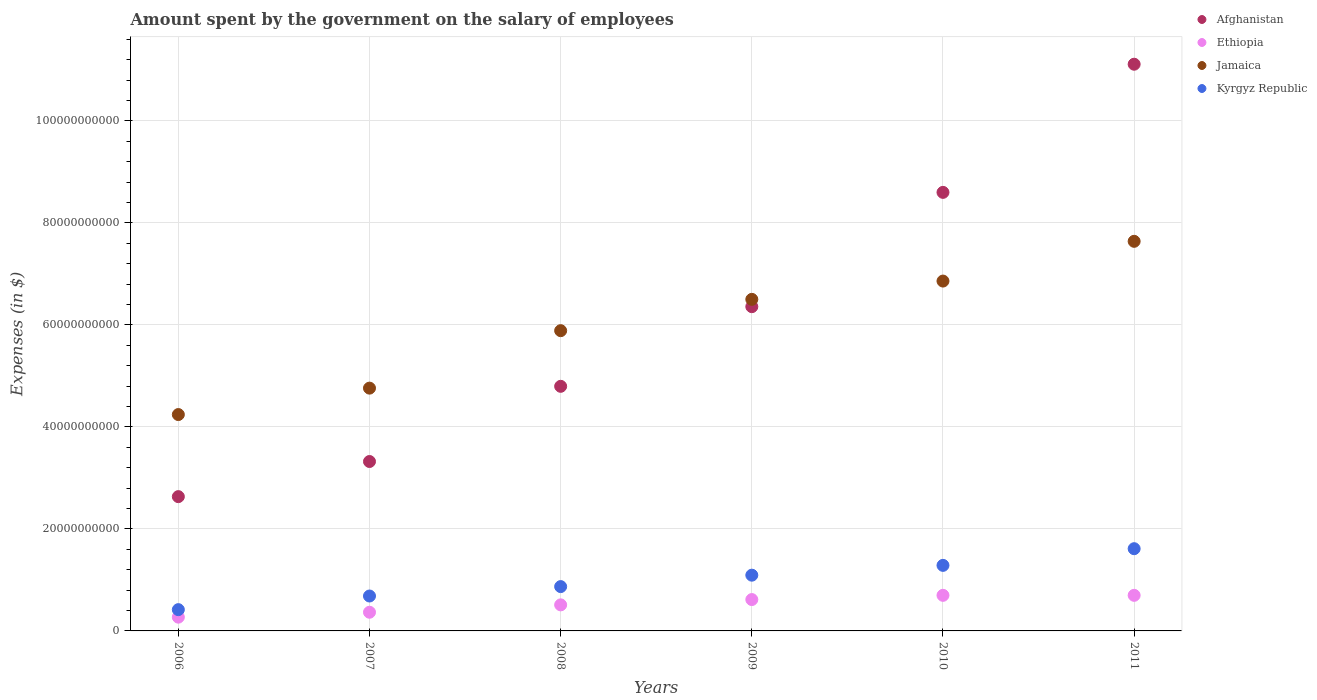Is the number of dotlines equal to the number of legend labels?
Your answer should be very brief. Yes. What is the amount spent on the salary of employees by the government in Afghanistan in 2011?
Offer a terse response. 1.11e+11. Across all years, what is the maximum amount spent on the salary of employees by the government in Afghanistan?
Your answer should be very brief. 1.11e+11. Across all years, what is the minimum amount spent on the salary of employees by the government in Jamaica?
Offer a terse response. 4.24e+1. In which year was the amount spent on the salary of employees by the government in Afghanistan maximum?
Your response must be concise. 2011. What is the total amount spent on the salary of employees by the government in Afghanistan in the graph?
Make the answer very short. 3.68e+11. What is the difference between the amount spent on the salary of employees by the government in Kyrgyz Republic in 2007 and that in 2011?
Your response must be concise. -9.28e+09. What is the difference between the amount spent on the salary of employees by the government in Kyrgyz Republic in 2011 and the amount spent on the salary of employees by the government in Afghanistan in 2007?
Your answer should be compact. -1.71e+1. What is the average amount spent on the salary of employees by the government in Afghanistan per year?
Keep it short and to the point. 6.14e+1. In the year 2008, what is the difference between the amount spent on the salary of employees by the government in Kyrgyz Republic and amount spent on the salary of employees by the government in Jamaica?
Offer a terse response. -5.02e+1. In how many years, is the amount spent on the salary of employees by the government in Ethiopia greater than 84000000000 $?
Your response must be concise. 0. What is the ratio of the amount spent on the salary of employees by the government in Kyrgyz Republic in 2007 to that in 2010?
Your answer should be very brief. 0.53. What is the difference between the highest and the second highest amount spent on the salary of employees by the government in Kyrgyz Republic?
Your answer should be very brief. 3.27e+09. What is the difference between the highest and the lowest amount spent on the salary of employees by the government in Kyrgyz Republic?
Provide a succinct answer. 1.20e+1. In how many years, is the amount spent on the salary of employees by the government in Kyrgyz Republic greater than the average amount spent on the salary of employees by the government in Kyrgyz Republic taken over all years?
Your response must be concise. 3. Is it the case that in every year, the sum of the amount spent on the salary of employees by the government in Afghanistan and amount spent on the salary of employees by the government in Ethiopia  is greater than the sum of amount spent on the salary of employees by the government in Kyrgyz Republic and amount spent on the salary of employees by the government in Jamaica?
Offer a very short reply. No. Is the amount spent on the salary of employees by the government in Jamaica strictly greater than the amount spent on the salary of employees by the government in Afghanistan over the years?
Offer a terse response. No. Is the amount spent on the salary of employees by the government in Afghanistan strictly less than the amount spent on the salary of employees by the government in Ethiopia over the years?
Provide a short and direct response. No. How many years are there in the graph?
Offer a terse response. 6. Are the values on the major ticks of Y-axis written in scientific E-notation?
Provide a succinct answer. No. Does the graph contain any zero values?
Offer a terse response. No. Does the graph contain grids?
Give a very brief answer. Yes. Where does the legend appear in the graph?
Keep it short and to the point. Top right. How many legend labels are there?
Give a very brief answer. 4. How are the legend labels stacked?
Keep it short and to the point. Vertical. What is the title of the graph?
Your response must be concise. Amount spent by the government on the salary of employees. What is the label or title of the X-axis?
Give a very brief answer. Years. What is the label or title of the Y-axis?
Ensure brevity in your answer.  Expenses (in $). What is the Expenses (in $) in Afghanistan in 2006?
Your answer should be very brief. 2.63e+1. What is the Expenses (in $) in Ethiopia in 2006?
Offer a very short reply. 2.70e+09. What is the Expenses (in $) in Jamaica in 2006?
Provide a short and direct response. 4.24e+1. What is the Expenses (in $) of Kyrgyz Republic in 2006?
Keep it short and to the point. 4.17e+09. What is the Expenses (in $) in Afghanistan in 2007?
Give a very brief answer. 3.32e+1. What is the Expenses (in $) of Ethiopia in 2007?
Give a very brief answer. 3.66e+09. What is the Expenses (in $) in Jamaica in 2007?
Your answer should be compact. 4.76e+1. What is the Expenses (in $) of Kyrgyz Republic in 2007?
Provide a succinct answer. 6.85e+09. What is the Expenses (in $) in Afghanistan in 2008?
Your answer should be compact. 4.80e+1. What is the Expenses (in $) in Ethiopia in 2008?
Make the answer very short. 5.11e+09. What is the Expenses (in $) of Jamaica in 2008?
Keep it short and to the point. 5.89e+1. What is the Expenses (in $) of Kyrgyz Republic in 2008?
Offer a terse response. 8.69e+09. What is the Expenses (in $) in Afghanistan in 2009?
Offer a very short reply. 6.36e+1. What is the Expenses (in $) of Ethiopia in 2009?
Keep it short and to the point. 6.15e+09. What is the Expenses (in $) of Jamaica in 2009?
Your answer should be compact. 6.50e+1. What is the Expenses (in $) of Kyrgyz Republic in 2009?
Provide a short and direct response. 1.09e+1. What is the Expenses (in $) in Afghanistan in 2010?
Your answer should be very brief. 8.60e+1. What is the Expenses (in $) of Ethiopia in 2010?
Give a very brief answer. 6.98e+09. What is the Expenses (in $) of Jamaica in 2010?
Make the answer very short. 6.86e+1. What is the Expenses (in $) of Kyrgyz Republic in 2010?
Your answer should be very brief. 1.29e+1. What is the Expenses (in $) of Afghanistan in 2011?
Your answer should be compact. 1.11e+11. What is the Expenses (in $) of Ethiopia in 2011?
Your answer should be very brief. 6.98e+09. What is the Expenses (in $) in Jamaica in 2011?
Offer a terse response. 7.64e+1. What is the Expenses (in $) in Kyrgyz Republic in 2011?
Your answer should be compact. 1.61e+1. Across all years, what is the maximum Expenses (in $) in Afghanistan?
Give a very brief answer. 1.11e+11. Across all years, what is the maximum Expenses (in $) in Ethiopia?
Offer a very short reply. 6.98e+09. Across all years, what is the maximum Expenses (in $) of Jamaica?
Offer a very short reply. 7.64e+1. Across all years, what is the maximum Expenses (in $) of Kyrgyz Republic?
Offer a very short reply. 1.61e+1. Across all years, what is the minimum Expenses (in $) of Afghanistan?
Provide a short and direct response. 2.63e+1. Across all years, what is the minimum Expenses (in $) of Ethiopia?
Ensure brevity in your answer.  2.70e+09. Across all years, what is the minimum Expenses (in $) of Jamaica?
Provide a succinct answer. 4.24e+1. Across all years, what is the minimum Expenses (in $) of Kyrgyz Republic?
Provide a short and direct response. 4.17e+09. What is the total Expenses (in $) in Afghanistan in the graph?
Provide a short and direct response. 3.68e+11. What is the total Expenses (in $) in Ethiopia in the graph?
Ensure brevity in your answer.  3.16e+1. What is the total Expenses (in $) of Jamaica in the graph?
Provide a succinct answer. 3.59e+11. What is the total Expenses (in $) in Kyrgyz Republic in the graph?
Make the answer very short. 5.96e+1. What is the difference between the Expenses (in $) of Afghanistan in 2006 and that in 2007?
Your answer should be compact. -6.89e+09. What is the difference between the Expenses (in $) of Ethiopia in 2006 and that in 2007?
Provide a short and direct response. -9.63e+08. What is the difference between the Expenses (in $) of Jamaica in 2006 and that in 2007?
Keep it short and to the point. -5.18e+09. What is the difference between the Expenses (in $) in Kyrgyz Republic in 2006 and that in 2007?
Keep it short and to the point. -2.67e+09. What is the difference between the Expenses (in $) in Afghanistan in 2006 and that in 2008?
Offer a terse response. -2.16e+1. What is the difference between the Expenses (in $) of Ethiopia in 2006 and that in 2008?
Provide a succinct answer. -2.41e+09. What is the difference between the Expenses (in $) of Jamaica in 2006 and that in 2008?
Make the answer very short. -1.64e+1. What is the difference between the Expenses (in $) of Kyrgyz Republic in 2006 and that in 2008?
Make the answer very short. -4.52e+09. What is the difference between the Expenses (in $) of Afghanistan in 2006 and that in 2009?
Provide a short and direct response. -3.72e+1. What is the difference between the Expenses (in $) of Ethiopia in 2006 and that in 2009?
Your response must be concise. -3.45e+09. What is the difference between the Expenses (in $) of Jamaica in 2006 and that in 2009?
Offer a very short reply. -2.26e+1. What is the difference between the Expenses (in $) in Kyrgyz Republic in 2006 and that in 2009?
Provide a short and direct response. -6.76e+09. What is the difference between the Expenses (in $) in Afghanistan in 2006 and that in 2010?
Provide a short and direct response. -5.97e+1. What is the difference between the Expenses (in $) in Ethiopia in 2006 and that in 2010?
Offer a terse response. -4.28e+09. What is the difference between the Expenses (in $) in Jamaica in 2006 and that in 2010?
Your response must be concise. -2.62e+1. What is the difference between the Expenses (in $) of Kyrgyz Republic in 2006 and that in 2010?
Your answer should be very brief. -8.68e+09. What is the difference between the Expenses (in $) of Afghanistan in 2006 and that in 2011?
Your answer should be very brief. -8.48e+1. What is the difference between the Expenses (in $) in Ethiopia in 2006 and that in 2011?
Give a very brief answer. -4.28e+09. What is the difference between the Expenses (in $) of Jamaica in 2006 and that in 2011?
Offer a terse response. -3.40e+1. What is the difference between the Expenses (in $) of Kyrgyz Republic in 2006 and that in 2011?
Ensure brevity in your answer.  -1.20e+1. What is the difference between the Expenses (in $) in Afghanistan in 2007 and that in 2008?
Offer a very short reply. -1.47e+1. What is the difference between the Expenses (in $) of Ethiopia in 2007 and that in 2008?
Keep it short and to the point. -1.45e+09. What is the difference between the Expenses (in $) in Jamaica in 2007 and that in 2008?
Keep it short and to the point. -1.13e+1. What is the difference between the Expenses (in $) in Kyrgyz Republic in 2007 and that in 2008?
Provide a succinct answer. -1.85e+09. What is the difference between the Expenses (in $) in Afghanistan in 2007 and that in 2009?
Offer a terse response. -3.04e+1. What is the difference between the Expenses (in $) in Ethiopia in 2007 and that in 2009?
Your answer should be very brief. -2.49e+09. What is the difference between the Expenses (in $) of Jamaica in 2007 and that in 2009?
Give a very brief answer. -1.74e+1. What is the difference between the Expenses (in $) in Kyrgyz Republic in 2007 and that in 2009?
Your answer should be very brief. -4.09e+09. What is the difference between the Expenses (in $) in Afghanistan in 2007 and that in 2010?
Give a very brief answer. -5.28e+1. What is the difference between the Expenses (in $) of Ethiopia in 2007 and that in 2010?
Your response must be concise. -3.32e+09. What is the difference between the Expenses (in $) of Jamaica in 2007 and that in 2010?
Offer a very short reply. -2.10e+1. What is the difference between the Expenses (in $) of Kyrgyz Republic in 2007 and that in 2010?
Give a very brief answer. -6.01e+09. What is the difference between the Expenses (in $) of Afghanistan in 2007 and that in 2011?
Provide a succinct answer. -7.79e+1. What is the difference between the Expenses (in $) in Ethiopia in 2007 and that in 2011?
Ensure brevity in your answer.  -3.32e+09. What is the difference between the Expenses (in $) of Jamaica in 2007 and that in 2011?
Provide a short and direct response. -2.88e+1. What is the difference between the Expenses (in $) of Kyrgyz Republic in 2007 and that in 2011?
Your answer should be very brief. -9.28e+09. What is the difference between the Expenses (in $) of Afghanistan in 2008 and that in 2009?
Offer a terse response. -1.56e+1. What is the difference between the Expenses (in $) of Ethiopia in 2008 and that in 2009?
Your response must be concise. -1.04e+09. What is the difference between the Expenses (in $) of Jamaica in 2008 and that in 2009?
Offer a very short reply. -6.14e+09. What is the difference between the Expenses (in $) of Kyrgyz Republic in 2008 and that in 2009?
Offer a very short reply. -2.24e+09. What is the difference between the Expenses (in $) of Afghanistan in 2008 and that in 2010?
Offer a terse response. -3.80e+1. What is the difference between the Expenses (in $) of Ethiopia in 2008 and that in 2010?
Offer a terse response. -1.87e+09. What is the difference between the Expenses (in $) of Jamaica in 2008 and that in 2010?
Provide a short and direct response. -9.73e+09. What is the difference between the Expenses (in $) in Kyrgyz Republic in 2008 and that in 2010?
Provide a short and direct response. -4.16e+09. What is the difference between the Expenses (in $) in Afghanistan in 2008 and that in 2011?
Keep it short and to the point. -6.32e+1. What is the difference between the Expenses (in $) in Ethiopia in 2008 and that in 2011?
Provide a succinct answer. -1.87e+09. What is the difference between the Expenses (in $) in Jamaica in 2008 and that in 2011?
Your answer should be very brief. -1.75e+1. What is the difference between the Expenses (in $) in Kyrgyz Republic in 2008 and that in 2011?
Offer a very short reply. -7.43e+09. What is the difference between the Expenses (in $) of Afghanistan in 2009 and that in 2010?
Provide a succinct answer. -2.24e+1. What is the difference between the Expenses (in $) of Ethiopia in 2009 and that in 2010?
Your response must be concise. -8.29e+08. What is the difference between the Expenses (in $) of Jamaica in 2009 and that in 2010?
Your response must be concise. -3.59e+09. What is the difference between the Expenses (in $) of Kyrgyz Republic in 2009 and that in 2010?
Your answer should be compact. -1.92e+09. What is the difference between the Expenses (in $) of Afghanistan in 2009 and that in 2011?
Provide a succinct answer. -4.75e+1. What is the difference between the Expenses (in $) of Ethiopia in 2009 and that in 2011?
Your answer should be very brief. -8.29e+08. What is the difference between the Expenses (in $) in Jamaica in 2009 and that in 2011?
Your answer should be very brief. -1.14e+1. What is the difference between the Expenses (in $) in Kyrgyz Republic in 2009 and that in 2011?
Keep it short and to the point. -5.19e+09. What is the difference between the Expenses (in $) of Afghanistan in 2010 and that in 2011?
Ensure brevity in your answer.  -2.51e+1. What is the difference between the Expenses (in $) in Ethiopia in 2010 and that in 2011?
Keep it short and to the point. 0. What is the difference between the Expenses (in $) in Jamaica in 2010 and that in 2011?
Provide a short and direct response. -7.79e+09. What is the difference between the Expenses (in $) in Kyrgyz Republic in 2010 and that in 2011?
Your response must be concise. -3.27e+09. What is the difference between the Expenses (in $) in Afghanistan in 2006 and the Expenses (in $) in Ethiopia in 2007?
Offer a very short reply. 2.27e+1. What is the difference between the Expenses (in $) in Afghanistan in 2006 and the Expenses (in $) in Jamaica in 2007?
Give a very brief answer. -2.13e+1. What is the difference between the Expenses (in $) in Afghanistan in 2006 and the Expenses (in $) in Kyrgyz Republic in 2007?
Offer a terse response. 1.95e+1. What is the difference between the Expenses (in $) of Ethiopia in 2006 and the Expenses (in $) of Jamaica in 2007?
Give a very brief answer. -4.49e+1. What is the difference between the Expenses (in $) in Ethiopia in 2006 and the Expenses (in $) in Kyrgyz Republic in 2007?
Your answer should be compact. -4.15e+09. What is the difference between the Expenses (in $) of Jamaica in 2006 and the Expenses (in $) of Kyrgyz Republic in 2007?
Give a very brief answer. 3.56e+1. What is the difference between the Expenses (in $) in Afghanistan in 2006 and the Expenses (in $) in Ethiopia in 2008?
Offer a terse response. 2.12e+1. What is the difference between the Expenses (in $) in Afghanistan in 2006 and the Expenses (in $) in Jamaica in 2008?
Give a very brief answer. -3.25e+1. What is the difference between the Expenses (in $) of Afghanistan in 2006 and the Expenses (in $) of Kyrgyz Republic in 2008?
Offer a very short reply. 1.76e+1. What is the difference between the Expenses (in $) in Ethiopia in 2006 and the Expenses (in $) in Jamaica in 2008?
Offer a terse response. -5.62e+1. What is the difference between the Expenses (in $) of Ethiopia in 2006 and the Expenses (in $) of Kyrgyz Republic in 2008?
Your response must be concise. -5.99e+09. What is the difference between the Expenses (in $) of Jamaica in 2006 and the Expenses (in $) of Kyrgyz Republic in 2008?
Your answer should be compact. 3.37e+1. What is the difference between the Expenses (in $) of Afghanistan in 2006 and the Expenses (in $) of Ethiopia in 2009?
Ensure brevity in your answer.  2.02e+1. What is the difference between the Expenses (in $) of Afghanistan in 2006 and the Expenses (in $) of Jamaica in 2009?
Give a very brief answer. -3.87e+1. What is the difference between the Expenses (in $) of Afghanistan in 2006 and the Expenses (in $) of Kyrgyz Republic in 2009?
Offer a terse response. 1.54e+1. What is the difference between the Expenses (in $) in Ethiopia in 2006 and the Expenses (in $) in Jamaica in 2009?
Offer a very short reply. -6.23e+1. What is the difference between the Expenses (in $) in Ethiopia in 2006 and the Expenses (in $) in Kyrgyz Republic in 2009?
Your answer should be very brief. -8.23e+09. What is the difference between the Expenses (in $) of Jamaica in 2006 and the Expenses (in $) of Kyrgyz Republic in 2009?
Your response must be concise. 3.15e+1. What is the difference between the Expenses (in $) of Afghanistan in 2006 and the Expenses (in $) of Ethiopia in 2010?
Ensure brevity in your answer.  1.94e+1. What is the difference between the Expenses (in $) of Afghanistan in 2006 and the Expenses (in $) of Jamaica in 2010?
Your answer should be very brief. -4.23e+1. What is the difference between the Expenses (in $) in Afghanistan in 2006 and the Expenses (in $) in Kyrgyz Republic in 2010?
Provide a short and direct response. 1.35e+1. What is the difference between the Expenses (in $) of Ethiopia in 2006 and the Expenses (in $) of Jamaica in 2010?
Give a very brief answer. -6.59e+1. What is the difference between the Expenses (in $) in Ethiopia in 2006 and the Expenses (in $) in Kyrgyz Republic in 2010?
Your answer should be very brief. -1.02e+1. What is the difference between the Expenses (in $) in Jamaica in 2006 and the Expenses (in $) in Kyrgyz Republic in 2010?
Offer a terse response. 2.96e+1. What is the difference between the Expenses (in $) of Afghanistan in 2006 and the Expenses (in $) of Ethiopia in 2011?
Your response must be concise. 1.94e+1. What is the difference between the Expenses (in $) of Afghanistan in 2006 and the Expenses (in $) of Jamaica in 2011?
Give a very brief answer. -5.01e+1. What is the difference between the Expenses (in $) in Afghanistan in 2006 and the Expenses (in $) in Kyrgyz Republic in 2011?
Give a very brief answer. 1.02e+1. What is the difference between the Expenses (in $) of Ethiopia in 2006 and the Expenses (in $) of Jamaica in 2011?
Offer a terse response. -7.37e+1. What is the difference between the Expenses (in $) of Ethiopia in 2006 and the Expenses (in $) of Kyrgyz Republic in 2011?
Offer a terse response. -1.34e+1. What is the difference between the Expenses (in $) in Jamaica in 2006 and the Expenses (in $) in Kyrgyz Republic in 2011?
Provide a short and direct response. 2.63e+1. What is the difference between the Expenses (in $) of Afghanistan in 2007 and the Expenses (in $) of Ethiopia in 2008?
Offer a terse response. 2.81e+1. What is the difference between the Expenses (in $) of Afghanistan in 2007 and the Expenses (in $) of Jamaica in 2008?
Ensure brevity in your answer.  -2.57e+1. What is the difference between the Expenses (in $) of Afghanistan in 2007 and the Expenses (in $) of Kyrgyz Republic in 2008?
Ensure brevity in your answer.  2.45e+1. What is the difference between the Expenses (in $) in Ethiopia in 2007 and the Expenses (in $) in Jamaica in 2008?
Offer a very short reply. -5.52e+1. What is the difference between the Expenses (in $) of Ethiopia in 2007 and the Expenses (in $) of Kyrgyz Republic in 2008?
Offer a terse response. -5.03e+09. What is the difference between the Expenses (in $) in Jamaica in 2007 and the Expenses (in $) in Kyrgyz Republic in 2008?
Offer a terse response. 3.89e+1. What is the difference between the Expenses (in $) of Afghanistan in 2007 and the Expenses (in $) of Ethiopia in 2009?
Provide a succinct answer. 2.71e+1. What is the difference between the Expenses (in $) in Afghanistan in 2007 and the Expenses (in $) in Jamaica in 2009?
Provide a short and direct response. -3.18e+1. What is the difference between the Expenses (in $) of Afghanistan in 2007 and the Expenses (in $) of Kyrgyz Republic in 2009?
Provide a short and direct response. 2.23e+1. What is the difference between the Expenses (in $) in Ethiopia in 2007 and the Expenses (in $) in Jamaica in 2009?
Offer a very short reply. -6.14e+1. What is the difference between the Expenses (in $) of Ethiopia in 2007 and the Expenses (in $) of Kyrgyz Republic in 2009?
Your answer should be very brief. -7.27e+09. What is the difference between the Expenses (in $) of Jamaica in 2007 and the Expenses (in $) of Kyrgyz Republic in 2009?
Ensure brevity in your answer.  3.67e+1. What is the difference between the Expenses (in $) of Afghanistan in 2007 and the Expenses (in $) of Ethiopia in 2010?
Your answer should be very brief. 2.62e+1. What is the difference between the Expenses (in $) in Afghanistan in 2007 and the Expenses (in $) in Jamaica in 2010?
Offer a terse response. -3.54e+1. What is the difference between the Expenses (in $) in Afghanistan in 2007 and the Expenses (in $) in Kyrgyz Republic in 2010?
Make the answer very short. 2.04e+1. What is the difference between the Expenses (in $) in Ethiopia in 2007 and the Expenses (in $) in Jamaica in 2010?
Provide a succinct answer. -6.49e+1. What is the difference between the Expenses (in $) in Ethiopia in 2007 and the Expenses (in $) in Kyrgyz Republic in 2010?
Provide a succinct answer. -9.19e+09. What is the difference between the Expenses (in $) in Jamaica in 2007 and the Expenses (in $) in Kyrgyz Republic in 2010?
Make the answer very short. 3.48e+1. What is the difference between the Expenses (in $) in Afghanistan in 2007 and the Expenses (in $) in Ethiopia in 2011?
Provide a succinct answer. 2.62e+1. What is the difference between the Expenses (in $) in Afghanistan in 2007 and the Expenses (in $) in Jamaica in 2011?
Your answer should be very brief. -4.32e+1. What is the difference between the Expenses (in $) of Afghanistan in 2007 and the Expenses (in $) of Kyrgyz Republic in 2011?
Offer a very short reply. 1.71e+1. What is the difference between the Expenses (in $) in Ethiopia in 2007 and the Expenses (in $) in Jamaica in 2011?
Ensure brevity in your answer.  -7.27e+1. What is the difference between the Expenses (in $) in Ethiopia in 2007 and the Expenses (in $) in Kyrgyz Republic in 2011?
Keep it short and to the point. -1.25e+1. What is the difference between the Expenses (in $) in Jamaica in 2007 and the Expenses (in $) in Kyrgyz Republic in 2011?
Offer a very short reply. 3.15e+1. What is the difference between the Expenses (in $) of Afghanistan in 2008 and the Expenses (in $) of Ethiopia in 2009?
Make the answer very short. 4.18e+1. What is the difference between the Expenses (in $) in Afghanistan in 2008 and the Expenses (in $) in Jamaica in 2009?
Offer a very short reply. -1.71e+1. What is the difference between the Expenses (in $) of Afghanistan in 2008 and the Expenses (in $) of Kyrgyz Republic in 2009?
Give a very brief answer. 3.70e+1. What is the difference between the Expenses (in $) in Ethiopia in 2008 and the Expenses (in $) in Jamaica in 2009?
Offer a very short reply. -5.99e+1. What is the difference between the Expenses (in $) in Ethiopia in 2008 and the Expenses (in $) in Kyrgyz Republic in 2009?
Provide a succinct answer. -5.82e+09. What is the difference between the Expenses (in $) of Jamaica in 2008 and the Expenses (in $) of Kyrgyz Republic in 2009?
Offer a very short reply. 4.79e+1. What is the difference between the Expenses (in $) in Afghanistan in 2008 and the Expenses (in $) in Ethiopia in 2010?
Provide a succinct answer. 4.10e+1. What is the difference between the Expenses (in $) of Afghanistan in 2008 and the Expenses (in $) of Jamaica in 2010?
Offer a very short reply. -2.06e+1. What is the difference between the Expenses (in $) of Afghanistan in 2008 and the Expenses (in $) of Kyrgyz Republic in 2010?
Ensure brevity in your answer.  3.51e+1. What is the difference between the Expenses (in $) of Ethiopia in 2008 and the Expenses (in $) of Jamaica in 2010?
Ensure brevity in your answer.  -6.35e+1. What is the difference between the Expenses (in $) in Ethiopia in 2008 and the Expenses (in $) in Kyrgyz Republic in 2010?
Your response must be concise. -7.74e+09. What is the difference between the Expenses (in $) in Jamaica in 2008 and the Expenses (in $) in Kyrgyz Republic in 2010?
Ensure brevity in your answer.  4.60e+1. What is the difference between the Expenses (in $) in Afghanistan in 2008 and the Expenses (in $) in Ethiopia in 2011?
Your response must be concise. 4.10e+1. What is the difference between the Expenses (in $) in Afghanistan in 2008 and the Expenses (in $) in Jamaica in 2011?
Your response must be concise. -2.84e+1. What is the difference between the Expenses (in $) of Afghanistan in 2008 and the Expenses (in $) of Kyrgyz Republic in 2011?
Provide a succinct answer. 3.18e+1. What is the difference between the Expenses (in $) in Ethiopia in 2008 and the Expenses (in $) in Jamaica in 2011?
Offer a very short reply. -7.13e+1. What is the difference between the Expenses (in $) in Ethiopia in 2008 and the Expenses (in $) in Kyrgyz Republic in 2011?
Make the answer very short. -1.10e+1. What is the difference between the Expenses (in $) in Jamaica in 2008 and the Expenses (in $) in Kyrgyz Republic in 2011?
Your response must be concise. 4.27e+1. What is the difference between the Expenses (in $) of Afghanistan in 2009 and the Expenses (in $) of Ethiopia in 2010?
Ensure brevity in your answer.  5.66e+1. What is the difference between the Expenses (in $) of Afghanistan in 2009 and the Expenses (in $) of Jamaica in 2010?
Offer a very short reply. -5.02e+09. What is the difference between the Expenses (in $) of Afghanistan in 2009 and the Expenses (in $) of Kyrgyz Republic in 2010?
Your answer should be compact. 5.07e+1. What is the difference between the Expenses (in $) of Ethiopia in 2009 and the Expenses (in $) of Jamaica in 2010?
Give a very brief answer. -6.25e+1. What is the difference between the Expenses (in $) of Ethiopia in 2009 and the Expenses (in $) of Kyrgyz Republic in 2010?
Provide a succinct answer. -6.70e+09. What is the difference between the Expenses (in $) in Jamaica in 2009 and the Expenses (in $) in Kyrgyz Republic in 2010?
Your answer should be compact. 5.22e+1. What is the difference between the Expenses (in $) in Afghanistan in 2009 and the Expenses (in $) in Ethiopia in 2011?
Keep it short and to the point. 5.66e+1. What is the difference between the Expenses (in $) in Afghanistan in 2009 and the Expenses (in $) in Jamaica in 2011?
Make the answer very short. -1.28e+1. What is the difference between the Expenses (in $) in Afghanistan in 2009 and the Expenses (in $) in Kyrgyz Republic in 2011?
Offer a very short reply. 4.75e+1. What is the difference between the Expenses (in $) in Ethiopia in 2009 and the Expenses (in $) in Jamaica in 2011?
Provide a succinct answer. -7.02e+1. What is the difference between the Expenses (in $) in Ethiopia in 2009 and the Expenses (in $) in Kyrgyz Republic in 2011?
Your response must be concise. -9.98e+09. What is the difference between the Expenses (in $) of Jamaica in 2009 and the Expenses (in $) of Kyrgyz Republic in 2011?
Your response must be concise. 4.89e+1. What is the difference between the Expenses (in $) of Afghanistan in 2010 and the Expenses (in $) of Ethiopia in 2011?
Give a very brief answer. 7.90e+1. What is the difference between the Expenses (in $) of Afghanistan in 2010 and the Expenses (in $) of Jamaica in 2011?
Ensure brevity in your answer.  9.60e+09. What is the difference between the Expenses (in $) in Afghanistan in 2010 and the Expenses (in $) in Kyrgyz Republic in 2011?
Give a very brief answer. 6.99e+1. What is the difference between the Expenses (in $) of Ethiopia in 2010 and the Expenses (in $) of Jamaica in 2011?
Your response must be concise. -6.94e+1. What is the difference between the Expenses (in $) in Ethiopia in 2010 and the Expenses (in $) in Kyrgyz Republic in 2011?
Make the answer very short. -9.15e+09. What is the difference between the Expenses (in $) of Jamaica in 2010 and the Expenses (in $) of Kyrgyz Republic in 2011?
Your answer should be very brief. 5.25e+1. What is the average Expenses (in $) of Afghanistan per year?
Give a very brief answer. 6.14e+1. What is the average Expenses (in $) in Ethiopia per year?
Your answer should be compact. 5.26e+09. What is the average Expenses (in $) of Jamaica per year?
Make the answer very short. 5.98e+1. What is the average Expenses (in $) of Kyrgyz Republic per year?
Give a very brief answer. 9.94e+09. In the year 2006, what is the difference between the Expenses (in $) of Afghanistan and Expenses (in $) of Ethiopia?
Keep it short and to the point. 2.36e+1. In the year 2006, what is the difference between the Expenses (in $) in Afghanistan and Expenses (in $) in Jamaica?
Offer a terse response. -1.61e+1. In the year 2006, what is the difference between the Expenses (in $) of Afghanistan and Expenses (in $) of Kyrgyz Republic?
Your answer should be very brief. 2.22e+1. In the year 2006, what is the difference between the Expenses (in $) in Ethiopia and Expenses (in $) in Jamaica?
Offer a terse response. -3.97e+1. In the year 2006, what is the difference between the Expenses (in $) of Ethiopia and Expenses (in $) of Kyrgyz Republic?
Your answer should be compact. -1.47e+09. In the year 2006, what is the difference between the Expenses (in $) of Jamaica and Expenses (in $) of Kyrgyz Republic?
Your response must be concise. 3.83e+1. In the year 2007, what is the difference between the Expenses (in $) in Afghanistan and Expenses (in $) in Ethiopia?
Make the answer very short. 2.96e+1. In the year 2007, what is the difference between the Expenses (in $) of Afghanistan and Expenses (in $) of Jamaica?
Provide a short and direct response. -1.44e+1. In the year 2007, what is the difference between the Expenses (in $) in Afghanistan and Expenses (in $) in Kyrgyz Republic?
Provide a short and direct response. 2.64e+1. In the year 2007, what is the difference between the Expenses (in $) in Ethiopia and Expenses (in $) in Jamaica?
Make the answer very short. -4.39e+1. In the year 2007, what is the difference between the Expenses (in $) of Ethiopia and Expenses (in $) of Kyrgyz Republic?
Keep it short and to the point. -3.18e+09. In the year 2007, what is the difference between the Expenses (in $) in Jamaica and Expenses (in $) in Kyrgyz Republic?
Provide a succinct answer. 4.08e+1. In the year 2008, what is the difference between the Expenses (in $) in Afghanistan and Expenses (in $) in Ethiopia?
Make the answer very short. 4.29e+1. In the year 2008, what is the difference between the Expenses (in $) in Afghanistan and Expenses (in $) in Jamaica?
Your answer should be very brief. -1.09e+1. In the year 2008, what is the difference between the Expenses (in $) in Afghanistan and Expenses (in $) in Kyrgyz Republic?
Offer a terse response. 3.93e+1. In the year 2008, what is the difference between the Expenses (in $) in Ethiopia and Expenses (in $) in Jamaica?
Provide a short and direct response. -5.38e+1. In the year 2008, what is the difference between the Expenses (in $) in Ethiopia and Expenses (in $) in Kyrgyz Republic?
Offer a terse response. -3.58e+09. In the year 2008, what is the difference between the Expenses (in $) in Jamaica and Expenses (in $) in Kyrgyz Republic?
Give a very brief answer. 5.02e+1. In the year 2009, what is the difference between the Expenses (in $) in Afghanistan and Expenses (in $) in Ethiopia?
Give a very brief answer. 5.74e+1. In the year 2009, what is the difference between the Expenses (in $) of Afghanistan and Expenses (in $) of Jamaica?
Keep it short and to the point. -1.44e+09. In the year 2009, what is the difference between the Expenses (in $) of Afghanistan and Expenses (in $) of Kyrgyz Republic?
Offer a terse response. 5.26e+1. In the year 2009, what is the difference between the Expenses (in $) of Ethiopia and Expenses (in $) of Jamaica?
Your response must be concise. -5.89e+1. In the year 2009, what is the difference between the Expenses (in $) in Ethiopia and Expenses (in $) in Kyrgyz Republic?
Provide a succinct answer. -4.78e+09. In the year 2009, what is the difference between the Expenses (in $) of Jamaica and Expenses (in $) of Kyrgyz Republic?
Your answer should be very brief. 5.41e+1. In the year 2010, what is the difference between the Expenses (in $) of Afghanistan and Expenses (in $) of Ethiopia?
Provide a short and direct response. 7.90e+1. In the year 2010, what is the difference between the Expenses (in $) of Afghanistan and Expenses (in $) of Jamaica?
Offer a terse response. 1.74e+1. In the year 2010, what is the difference between the Expenses (in $) of Afghanistan and Expenses (in $) of Kyrgyz Republic?
Offer a very short reply. 7.31e+1. In the year 2010, what is the difference between the Expenses (in $) of Ethiopia and Expenses (in $) of Jamaica?
Ensure brevity in your answer.  -6.16e+1. In the year 2010, what is the difference between the Expenses (in $) in Ethiopia and Expenses (in $) in Kyrgyz Republic?
Your response must be concise. -5.87e+09. In the year 2010, what is the difference between the Expenses (in $) of Jamaica and Expenses (in $) of Kyrgyz Republic?
Keep it short and to the point. 5.57e+1. In the year 2011, what is the difference between the Expenses (in $) in Afghanistan and Expenses (in $) in Ethiopia?
Your answer should be very brief. 1.04e+11. In the year 2011, what is the difference between the Expenses (in $) of Afghanistan and Expenses (in $) of Jamaica?
Your answer should be compact. 3.47e+1. In the year 2011, what is the difference between the Expenses (in $) of Afghanistan and Expenses (in $) of Kyrgyz Republic?
Give a very brief answer. 9.50e+1. In the year 2011, what is the difference between the Expenses (in $) of Ethiopia and Expenses (in $) of Jamaica?
Your response must be concise. -6.94e+1. In the year 2011, what is the difference between the Expenses (in $) in Ethiopia and Expenses (in $) in Kyrgyz Republic?
Keep it short and to the point. -9.15e+09. In the year 2011, what is the difference between the Expenses (in $) of Jamaica and Expenses (in $) of Kyrgyz Republic?
Give a very brief answer. 6.03e+1. What is the ratio of the Expenses (in $) in Afghanistan in 2006 to that in 2007?
Keep it short and to the point. 0.79. What is the ratio of the Expenses (in $) in Ethiopia in 2006 to that in 2007?
Your response must be concise. 0.74. What is the ratio of the Expenses (in $) of Jamaica in 2006 to that in 2007?
Your answer should be compact. 0.89. What is the ratio of the Expenses (in $) in Kyrgyz Republic in 2006 to that in 2007?
Your answer should be compact. 0.61. What is the ratio of the Expenses (in $) of Afghanistan in 2006 to that in 2008?
Your response must be concise. 0.55. What is the ratio of the Expenses (in $) in Ethiopia in 2006 to that in 2008?
Keep it short and to the point. 0.53. What is the ratio of the Expenses (in $) of Jamaica in 2006 to that in 2008?
Give a very brief answer. 0.72. What is the ratio of the Expenses (in $) of Kyrgyz Republic in 2006 to that in 2008?
Keep it short and to the point. 0.48. What is the ratio of the Expenses (in $) in Afghanistan in 2006 to that in 2009?
Your response must be concise. 0.41. What is the ratio of the Expenses (in $) in Ethiopia in 2006 to that in 2009?
Your answer should be very brief. 0.44. What is the ratio of the Expenses (in $) in Jamaica in 2006 to that in 2009?
Make the answer very short. 0.65. What is the ratio of the Expenses (in $) of Kyrgyz Republic in 2006 to that in 2009?
Offer a terse response. 0.38. What is the ratio of the Expenses (in $) of Afghanistan in 2006 to that in 2010?
Your response must be concise. 0.31. What is the ratio of the Expenses (in $) in Ethiopia in 2006 to that in 2010?
Make the answer very short. 0.39. What is the ratio of the Expenses (in $) of Jamaica in 2006 to that in 2010?
Provide a short and direct response. 0.62. What is the ratio of the Expenses (in $) of Kyrgyz Republic in 2006 to that in 2010?
Your answer should be very brief. 0.32. What is the ratio of the Expenses (in $) in Afghanistan in 2006 to that in 2011?
Provide a short and direct response. 0.24. What is the ratio of the Expenses (in $) of Ethiopia in 2006 to that in 2011?
Your answer should be compact. 0.39. What is the ratio of the Expenses (in $) of Jamaica in 2006 to that in 2011?
Provide a short and direct response. 0.56. What is the ratio of the Expenses (in $) in Kyrgyz Republic in 2006 to that in 2011?
Ensure brevity in your answer.  0.26. What is the ratio of the Expenses (in $) in Afghanistan in 2007 to that in 2008?
Keep it short and to the point. 0.69. What is the ratio of the Expenses (in $) in Ethiopia in 2007 to that in 2008?
Offer a very short reply. 0.72. What is the ratio of the Expenses (in $) in Jamaica in 2007 to that in 2008?
Offer a terse response. 0.81. What is the ratio of the Expenses (in $) in Kyrgyz Republic in 2007 to that in 2008?
Your answer should be compact. 0.79. What is the ratio of the Expenses (in $) in Afghanistan in 2007 to that in 2009?
Ensure brevity in your answer.  0.52. What is the ratio of the Expenses (in $) in Ethiopia in 2007 to that in 2009?
Your answer should be compact. 0.6. What is the ratio of the Expenses (in $) in Jamaica in 2007 to that in 2009?
Keep it short and to the point. 0.73. What is the ratio of the Expenses (in $) in Kyrgyz Republic in 2007 to that in 2009?
Offer a terse response. 0.63. What is the ratio of the Expenses (in $) in Afghanistan in 2007 to that in 2010?
Provide a succinct answer. 0.39. What is the ratio of the Expenses (in $) in Ethiopia in 2007 to that in 2010?
Keep it short and to the point. 0.52. What is the ratio of the Expenses (in $) of Jamaica in 2007 to that in 2010?
Offer a very short reply. 0.69. What is the ratio of the Expenses (in $) in Kyrgyz Republic in 2007 to that in 2010?
Your response must be concise. 0.53. What is the ratio of the Expenses (in $) of Afghanistan in 2007 to that in 2011?
Your answer should be compact. 0.3. What is the ratio of the Expenses (in $) in Ethiopia in 2007 to that in 2011?
Keep it short and to the point. 0.52. What is the ratio of the Expenses (in $) of Jamaica in 2007 to that in 2011?
Your response must be concise. 0.62. What is the ratio of the Expenses (in $) in Kyrgyz Republic in 2007 to that in 2011?
Your answer should be very brief. 0.42. What is the ratio of the Expenses (in $) of Afghanistan in 2008 to that in 2009?
Make the answer very short. 0.75. What is the ratio of the Expenses (in $) of Ethiopia in 2008 to that in 2009?
Make the answer very short. 0.83. What is the ratio of the Expenses (in $) in Jamaica in 2008 to that in 2009?
Make the answer very short. 0.91. What is the ratio of the Expenses (in $) in Kyrgyz Republic in 2008 to that in 2009?
Ensure brevity in your answer.  0.8. What is the ratio of the Expenses (in $) of Afghanistan in 2008 to that in 2010?
Ensure brevity in your answer.  0.56. What is the ratio of the Expenses (in $) of Ethiopia in 2008 to that in 2010?
Ensure brevity in your answer.  0.73. What is the ratio of the Expenses (in $) of Jamaica in 2008 to that in 2010?
Provide a succinct answer. 0.86. What is the ratio of the Expenses (in $) in Kyrgyz Republic in 2008 to that in 2010?
Offer a very short reply. 0.68. What is the ratio of the Expenses (in $) of Afghanistan in 2008 to that in 2011?
Offer a terse response. 0.43. What is the ratio of the Expenses (in $) in Ethiopia in 2008 to that in 2011?
Provide a succinct answer. 0.73. What is the ratio of the Expenses (in $) of Jamaica in 2008 to that in 2011?
Provide a short and direct response. 0.77. What is the ratio of the Expenses (in $) of Kyrgyz Republic in 2008 to that in 2011?
Keep it short and to the point. 0.54. What is the ratio of the Expenses (in $) of Afghanistan in 2009 to that in 2010?
Ensure brevity in your answer.  0.74. What is the ratio of the Expenses (in $) of Ethiopia in 2009 to that in 2010?
Offer a terse response. 0.88. What is the ratio of the Expenses (in $) in Jamaica in 2009 to that in 2010?
Provide a succinct answer. 0.95. What is the ratio of the Expenses (in $) in Kyrgyz Republic in 2009 to that in 2010?
Ensure brevity in your answer.  0.85. What is the ratio of the Expenses (in $) of Afghanistan in 2009 to that in 2011?
Your answer should be very brief. 0.57. What is the ratio of the Expenses (in $) in Ethiopia in 2009 to that in 2011?
Your answer should be very brief. 0.88. What is the ratio of the Expenses (in $) of Jamaica in 2009 to that in 2011?
Your response must be concise. 0.85. What is the ratio of the Expenses (in $) of Kyrgyz Republic in 2009 to that in 2011?
Offer a very short reply. 0.68. What is the ratio of the Expenses (in $) in Afghanistan in 2010 to that in 2011?
Provide a succinct answer. 0.77. What is the ratio of the Expenses (in $) of Ethiopia in 2010 to that in 2011?
Provide a short and direct response. 1. What is the ratio of the Expenses (in $) in Jamaica in 2010 to that in 2011?
Offer a terse response. 0.9. What is the ratio of the Expenses (in $) in Kyrgyz Republic in 2010 to that in 2011?
Your answer should be very brief. 0.8. What is the difference between the highest and the second highest Expenses (in $) of Afghanistan?
Make the answer very short. 2.51e+1. What is the difference between the highest and the second highest Expenses (in $) of Jamaica?
Make the answer very short. 7.79e+09. What is the difference between the highest and the second highest Expenses (in $) of Kyrgyz Republic?
Your response must be concise. 3.27e+09. What is the difference between the highest and the lowest Expenses (in $) in Afghanistan?
Your response must be concise. 8.48e+1. What is the difference between the highest and the lowest Expenses (in $) of Ethiopia?
Give a very brief answer. 4.28e+09. What is the difference between the highest and the lowest Expenses (in $) of Jamaica?
Offer a terse response. 3.40e+1. What is the difference between the highest and the lowest Expenses (in $) in Kyrgyz Republic?
Provide a succinct answer. 1.20e+1. 